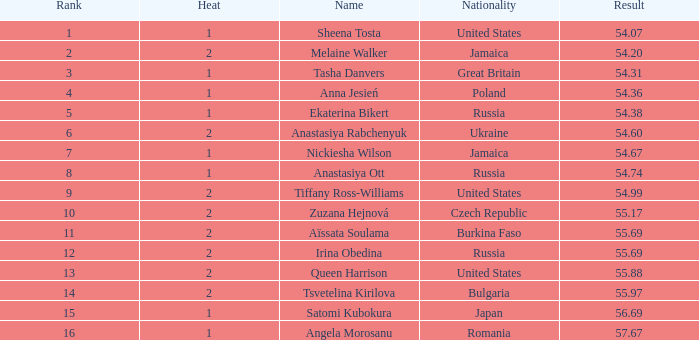97? None. 